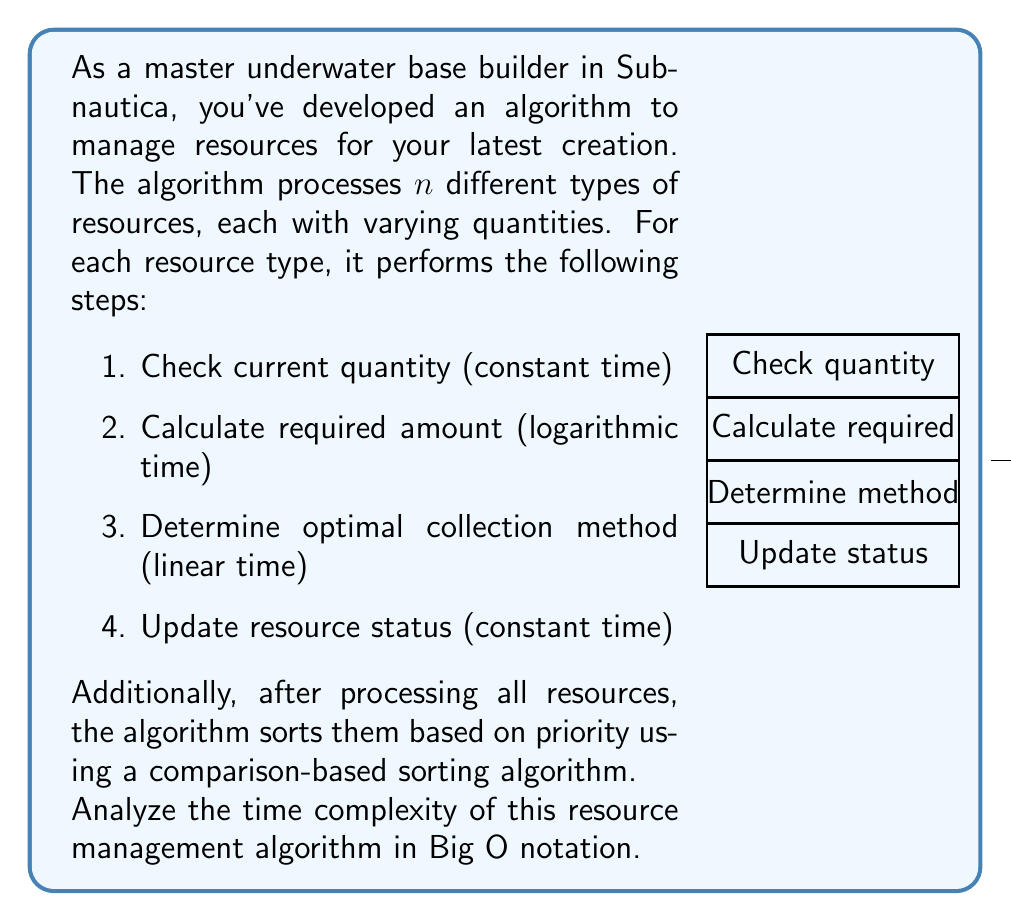What is the answer to this math problem? Let's analyze the time complexity step by step:

1) For each of the $n$ resources:
   a) Checking current quantity: $O(1)$
   b) Calculating required amount: $O(\log n)$
   c) Determining optimal collection method: $O(n)$
   d) Updating resource status: $O(1)$

   The time complexity for processing one resource is:
   $O(1) + O(\log n) + O(n) + O(1) = O(n)$

2) This is done for all $n$ resources, so the total time for processing all resources is:
   $n \cdot O(n) = O(n^2)$

3) After processing, the algorithm sorts the resources. The best comparison-based sorting algorithms have a time complexity of $O(n \log n)$

4) The total time complexity is the sum of processing and sorting:
   $O(n^2) + O(n \log n)$

5) In Big O notation, we only keep the most significant term. Since $n^2$ grows faster than $n \log n$ for large $n$, we can simplify this to:
   $O(n^2)$

Therefore, the overall time complexity of the resource management algorithm is $O(n^2)$.
Answer: $O(n^2)$ 